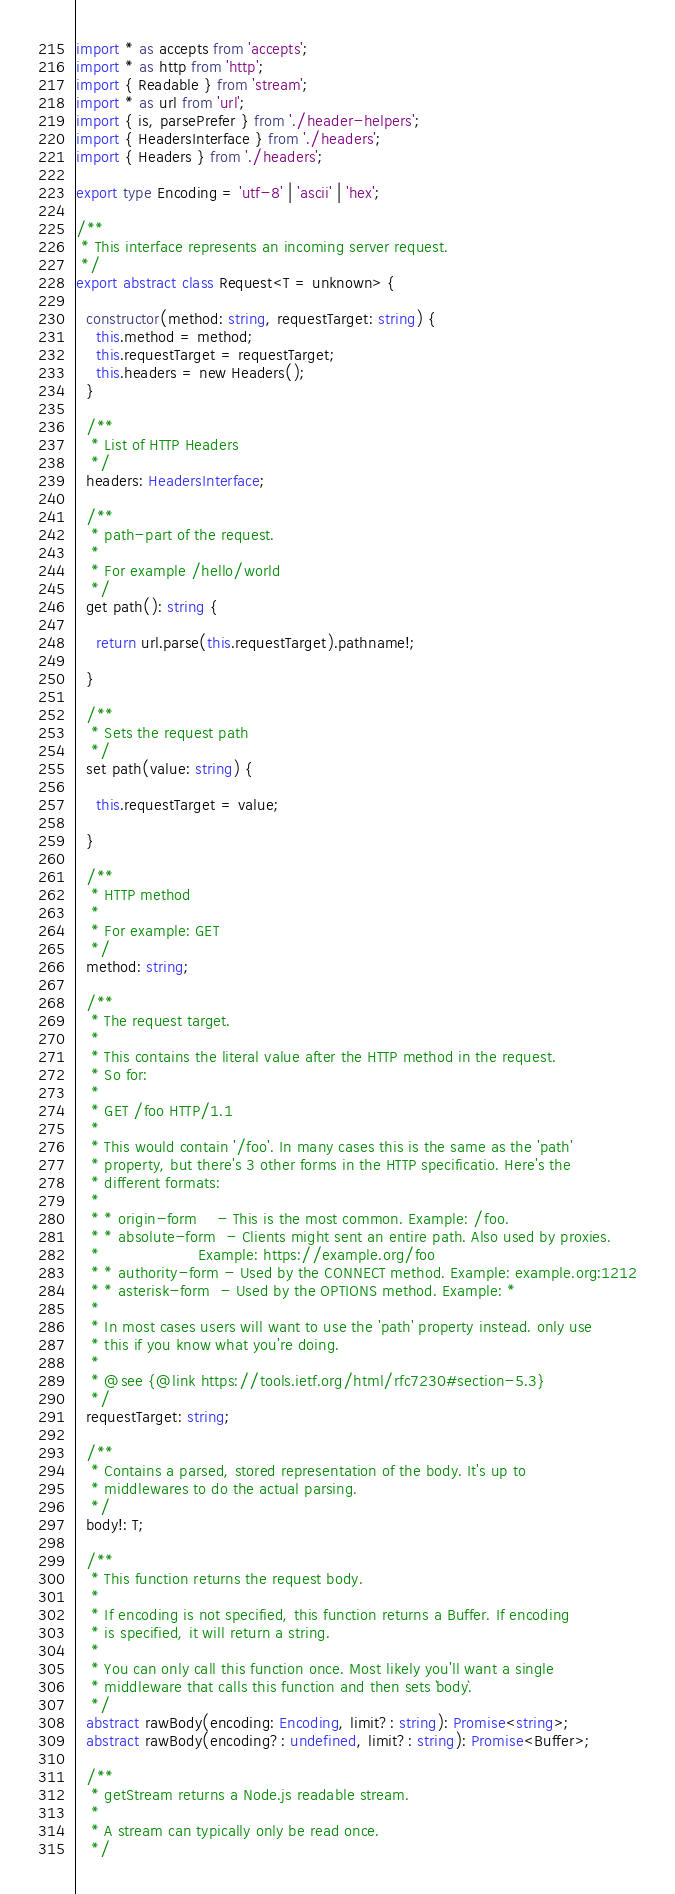Convert code to text. <code><loc_0><loc_0><loc_500><loc_500><_TypeScript_>import * as accepts from 'accepts';
import * as http from 'http';
import { Readable } from 'stream';
import * as url from 'url';
import { is, parsePrefer } from './header-helpers';
import { HeadersInterface } from './headers';
import { Headers } from './headers';

export type Encoding = 'utf-8' | 'ascii' | 'hex';

/**
 * This interface represents an incoming server request.
 */
export abstract class Request<T = unknown> {

  constructor(method: string, requestTarget: string) {
    this.method = method;
    this.requestTarget = requestTarget;
    this.headers = new Headers();
  }

  /**
   * List of HTTP Headers
   */
  headers: HeadersInterface;

  /**
   * path-part of the request.
   *
   * For example /hello/world
   */
  get path(): string {

    return url.parse(this.requestTarget).pathname!;

  }

  /**
   * Sets the request path
   */
  set path(value: string) {

    this.requestTarget = value;

  }

  /**
   * HTTP method
   *
   * For example: GET
   */
  method: string;

  /**
   * The request target.
   *
   * This contains the literal value after the HTTP method in the request.
   * So for:
   *
   * GET /foo HTTP/1.1
   *
   * This would contain '/foo'. In many cases this is the same as the 'path'
   * property, but there's 3 other forms in the HTTP specificatio. Here's the
   * different formats:
   *
   * * origin-form    - This is the most common. Example: /foo.
   * * absolute-form  - Clients might sent an entire path. Also used by proxies.
   *                    Example: https://example.org/foo
   * * authority-form - Used by the CONNECT method. Example: example.org:1212
   * * asterisk-form  - Used by the OPTIONS method. Example: *
   *
   * In most cases users will want to use the 'path' property instead. only use
   * this if you know what you're doing.
   *
   * @see {@link https://tools.ietf.org/html/rfc7230#section-5.3}
   */
  requestTarget: string;

  /**
   * Contains a parsed, stored representation of the body. It's up to
   * middlewares to do the actual parsing.
   */
  body!: T;

  /**
   * This function returns the request body.
   *
   * If encoding is not specified, this function returns a Buffer. If encoding
   * is specified, it will return a string.
   *
   * You can only call this function once. Most likely you'll want a single
   * middleware that calls this function and then sets `body`.
   */
  abstract rawBody(encoding: Encoding, limit?: string): Promise<string>;
  abstract rawBody(encoding?: undefined, limit?: string): Promise<Buffer>;

  /**
   * getStream returns a Node.js readable stream.
   *
   * A stream can typically only be read once.
   */</code> 